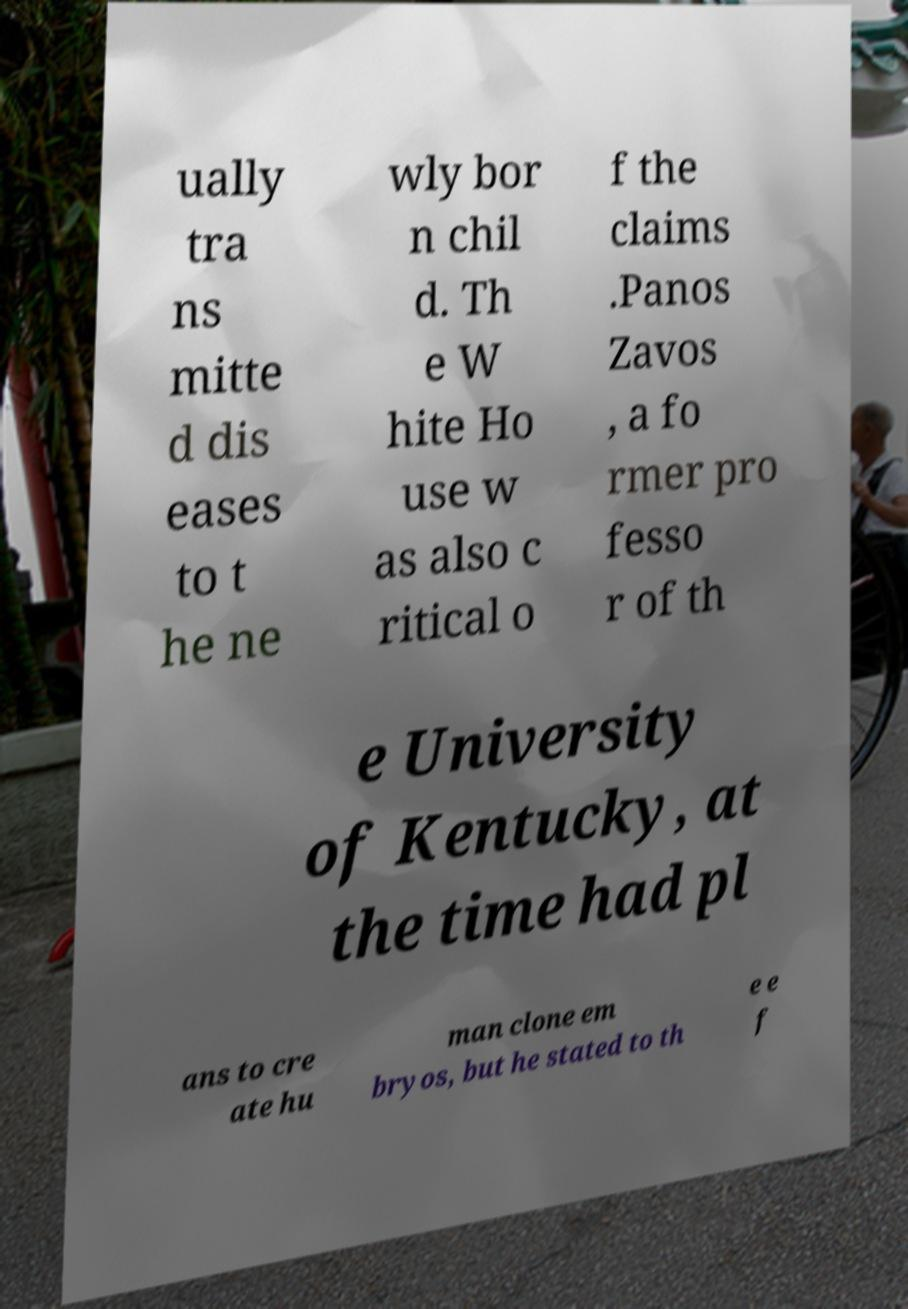I need the written content from this picture converted into text. Can you do that? ually tra ns mitte d dis eases to t he ne wly bor n chil d. Th e W hite Ho use w as also c ritical o f the claims .Panos Zavos , a fo rmer pro fesso r of th e University of Kentucky, at the time had pl ans to cre ate hu man clone em bryos, but he stated to th e e f 